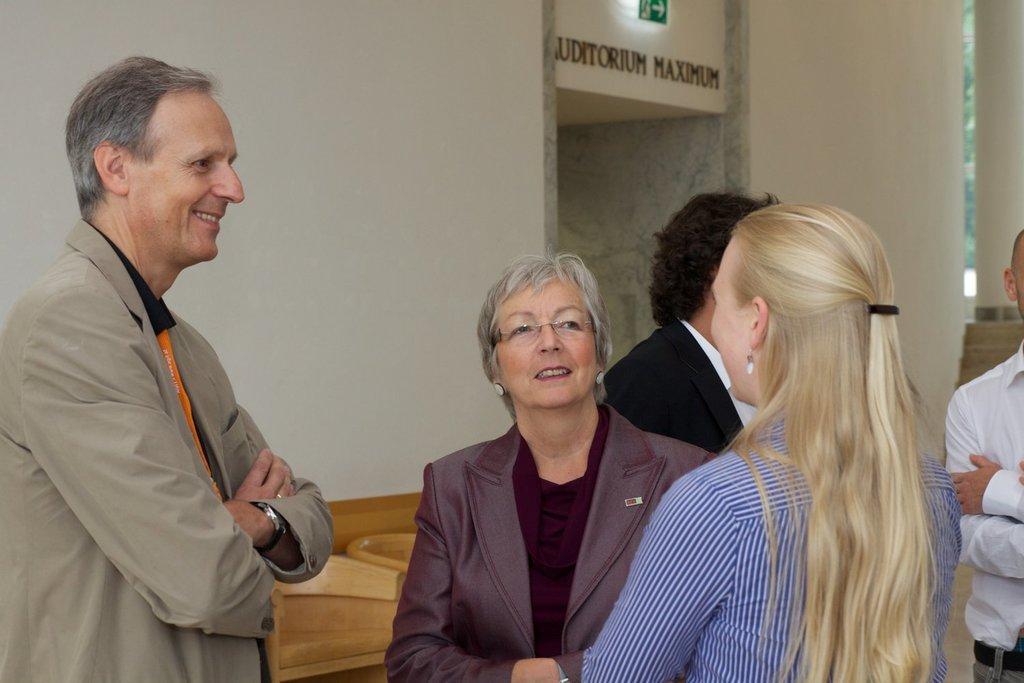In one or two sentences, can you explain what this image depicts? In this image there are people standing, there is an object behind the person, there is a wall behind the person, there is a board, there is text on the wall, there is a pillar towards the right of the image. 